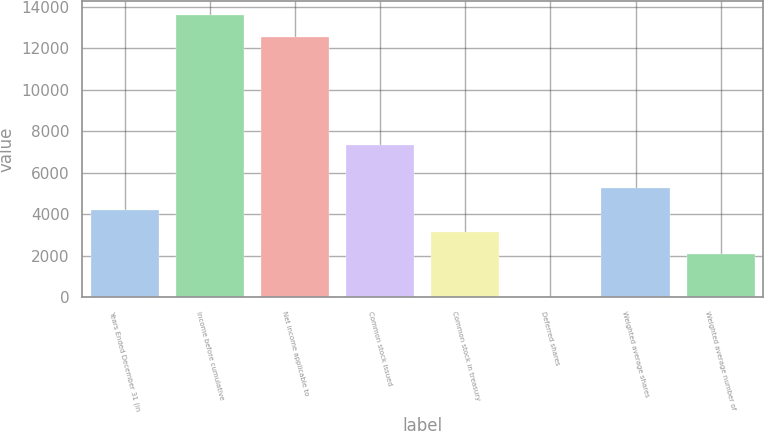Convert chart to OTSL. <chart><loc_0><loc_0><loc_500><loc_500><bar_chart><fcel>Years Ended December 31 (in<fcel>Income before cumulative<fcel>Net income applicable to<fcel>Common stock issued<fcel>Common stock in treasury<fcel>Deferred shares<fcel>Weighted average shares<fcel>Weighted average number of<nl><fcel>4195.8<fcel>13623.1<fcel>12574.4<fcel>7341.9<fcel>3147.1<fcel>1<fcel>5244.5<fcel>2098.4<nl></chart> 